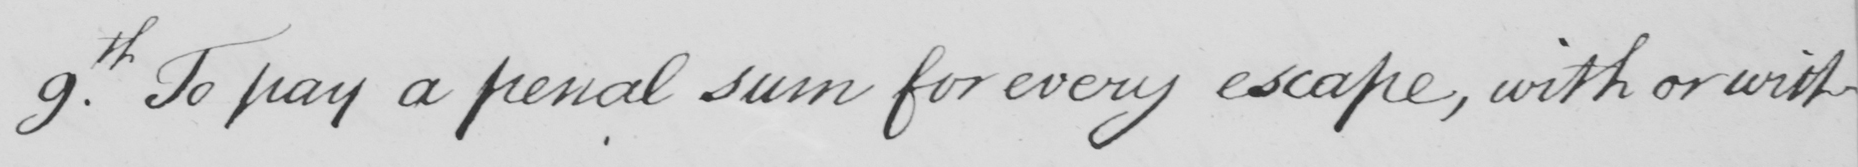Please transcribe the handwritten text in this image. 9th . To pay a penal sum for every escape , with or with- 